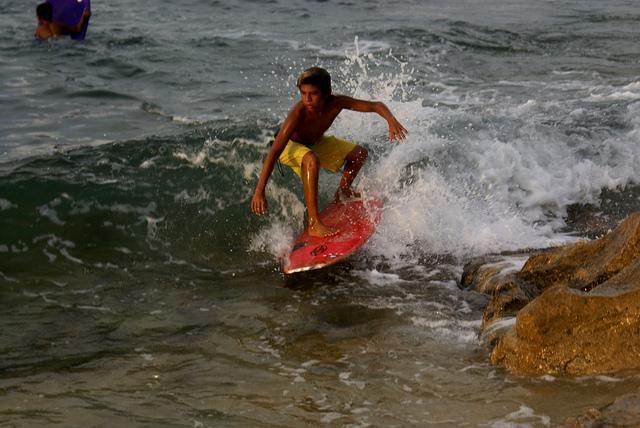What is the most obvious danger here?
Choose the correct response, then elucidate: 'Answer: answer
Rationale: rationale.'
Options: Car accident, brain freeze, rock collision, shark attack. Answer: rock collision.
Rationale: There are many stone, craggy parts there. 